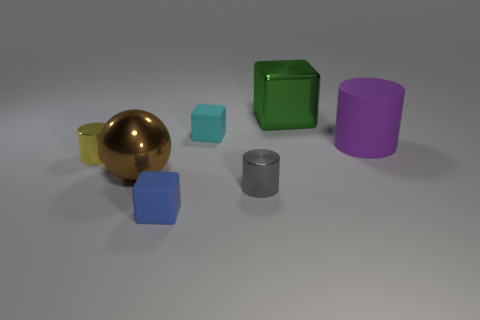Do the blue matte object and the metal cylinder to the left of the small blue matte thing have the same size?
Give a very brief answer. Yes. There is a small metal object right of the yellow object; what is its shape?
Keep it short and to the point. Cylinder. There is a small rubber object that is behind the cube in front of the gray metallic cylinder; is there a yellow thing that is right of it?
Offer a very short reply. No. What is the material of the large green thing that is the same shape as the tiny blue rubber thing?
Your response must be concise. Metal. Is there anything else that is made of the same material as the blue block?
Provide a succinct answer. Yes. What number of cylinders are large green shiny things or tiny yellow metallic things?
Keep it short and to the point. 1. There is a cylinder that is to the right of the small gray cylinder; does it have the same size as the matte block in front of the purple rubber object?
Provide a short and direct response. No. There is a large object that is on the left side of the metallic object on the right side of the gray object; what is its material?
Make the answer very short. Metal. Are there fewer large purple objects that are in front of the tiny gray cylinder than tiny gray metal objects?
Provide a succinct answer. Yes. The brown object that is the same material as the tiny yellow cylinder is what shape?
Ensure brevity in your answer.  Sphere. 